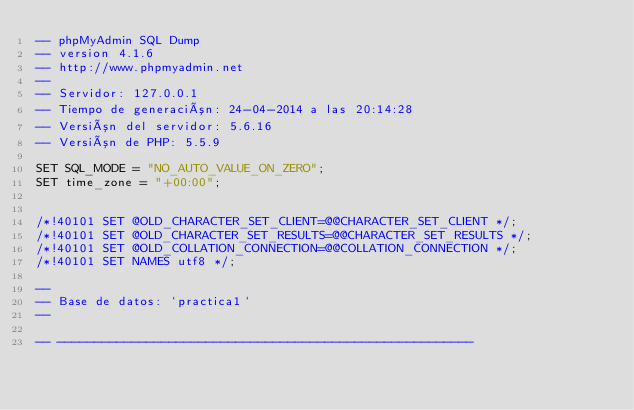Convert code to text. <code><loc_0><loc_0><loc_500><loc_500><_SQL_>-- phpMyAdmin SQL Dump
-- version 4.1.6
-- http://www.phpmyadmin.net
--
-- Servidor: 127.0.0.1
-- Tiempo de generación: 24-04-2014 a las 20:14:28
-- Versión del servidor: 5.6.16
-- Versión de PHP: 5.5.9

SET SQL_MODE = "NO_AUTO_VALUE_ON_ZERO";
SET time_zone = "+00:00";


/*!40101 SET @OLD_CHARACTER_SET_CLIENT=@@CHARACTER_SET_CLIENT */;
/*!40101 SET @OLD_CHARACTER_SET_RESULTS=@@CHARACTER_SET_RESULTS */;
/*!40101 SET @OLD_COLLATION_CONNECTION=@@COLLATION_CONNECTION */;
/*!40101 SET NAMES utf8 */;

--
-- Base de datos: `practica1`
--

-- --------------------------------------------------------
</code> 